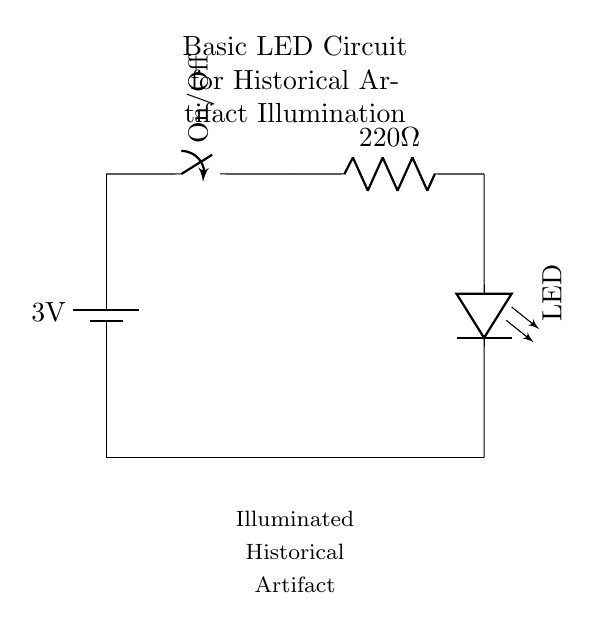What is the voltage of this circuit? The circuit shows a battery labeled with a voltage of 3V, indicating the potential difference it provides.
Answer: 3V What component controls the flow of electricity in this circuit? The circuit diagram includes a switch, which is specifically designed to open or close the circuit, controlling the flow of current.
Answer: Switch What is the resistance value shown in the circuit? A resistor is present in the circuit with a value marked as 220 ohms, which indicates how much it resists the flow of current.
Answer: 220 ohm What type of light source is used in this circuit? The circuit features an LED symbol, indicating that a light-emitting diode is used as the light source for illumination.
Answer: LED What happens when the switch is in the 'On' position? When the switch is closed (in the 'On' position), it allows current to flow from the battery through the resistor to the LED, illuminating the historical artifact.
Answer: Current flows Discuss the purpose of the resistor in this circuit. The resistor limits the amount of current that flows through the circuit, protecting the LED from excessive current that could damage it. Without the resistor, the LED could fail due to too much current.
Answer: Current limitation What does the circuit illuminate? The circuit is specifically designed to illuminate a historical artifact, as indicated by the annotation below the circuit diagram.
Answer: Historical artifact 